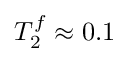Convert formula to latex. <formula><loc_0><loc_0><loc_500><loc_500>T _ { 2 } ^ { f } \approx 0 . 1</formula> 